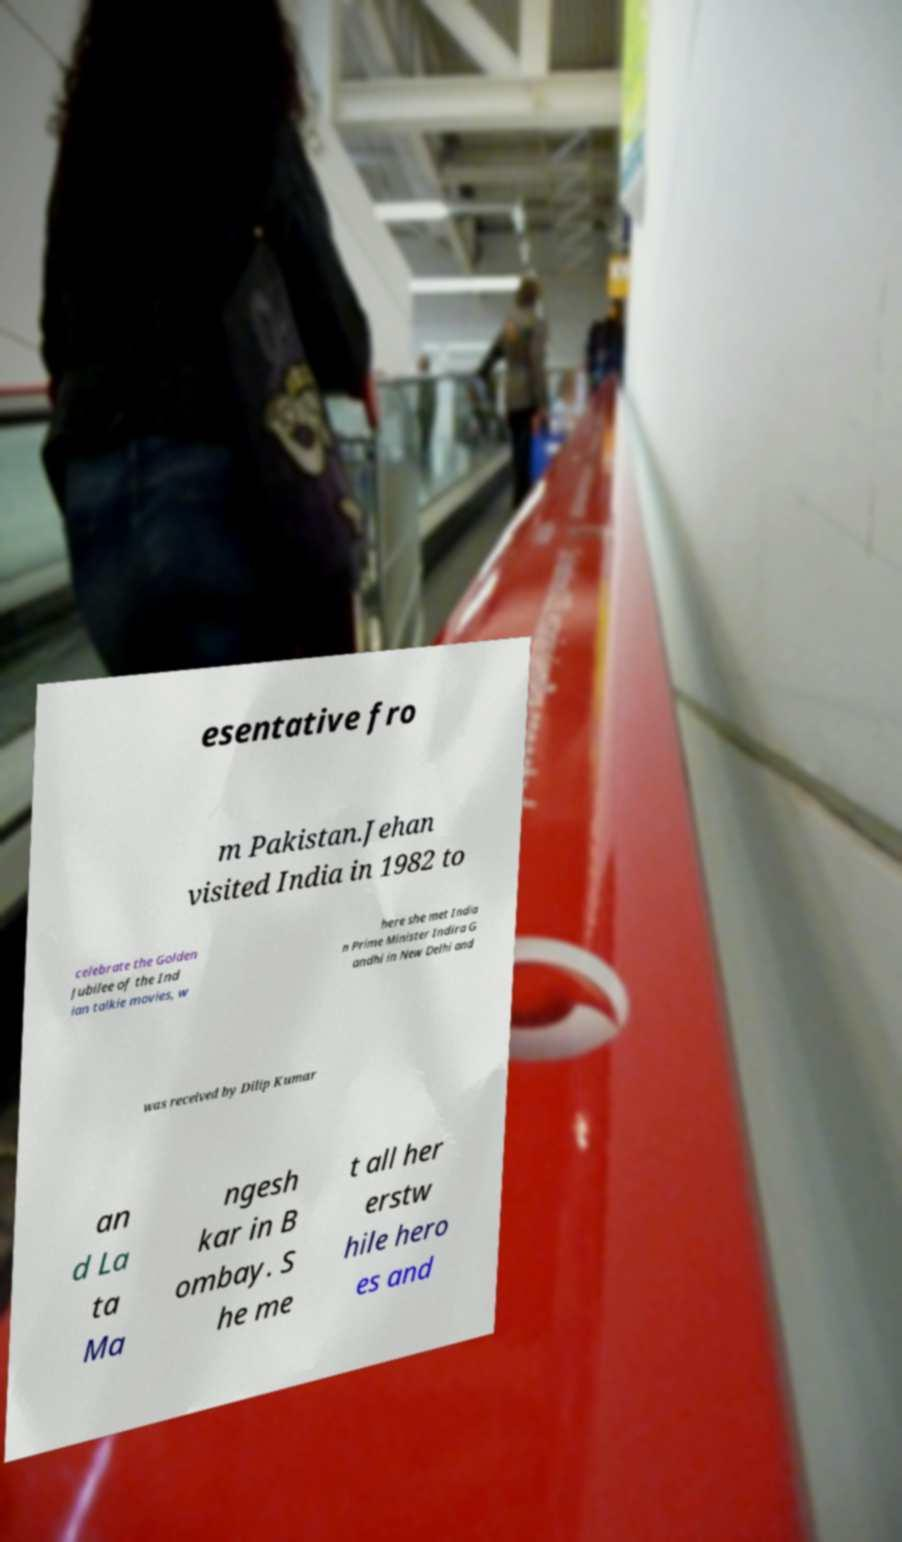Please read and relay the text visible in this image. What does it say? esentative fro m Pakistan.Jehan visited India in 1982 to celebrate the Golden Jubilee of the Ind ian talkie movies, w here she met India n Prime Minister Indira G andhi in New Delhi and was received by Dilip Kumar an d La ta Ma ngesh kar in B ombay. S he me t all her erstw hile hero es and 